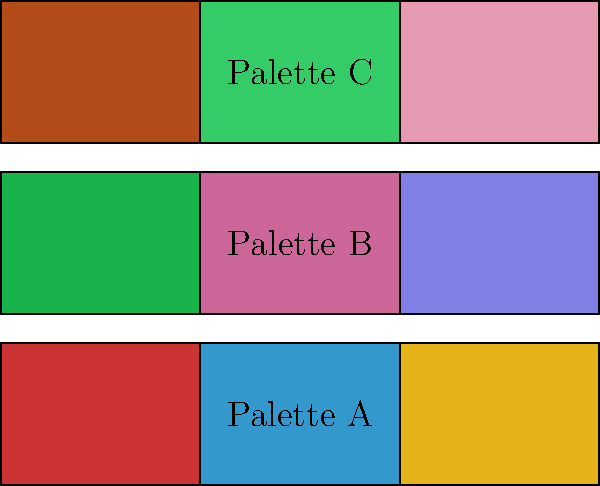Analyze the color palettes shown above, which are inspired by famous European street art murals. Which palette would be most effective for creating a mural that captures the vibrant energy of Barcelona's Las Ramblas district, and why? To answer this question, we need to consider the characteristics of Barcelona's Las Ramblas district and how each color palette might reflect its atmosphere:

1. Las Ramblas characteristics:
   - Vibrant and lively pedestrian street
   - Colorful flower stalls and street performers
   - Mediterranean influence with warm sunlight

2. Palette A analysis:
   - Contains warm red, cool blue, and bright yellow
   - High contrast and energy
   - Resembles the Spanish flag colors (red and yellow)

3. Palette B analysis:
   - Consists of cool green, warm pink, and muted blue
   - Softer contrast and more subdued energy
   - Lacks warm, vibrant tones associated with Mediterranean atmosphere

4. Palette C analysis:
   - Features warm terracotta, bright green, and soft pink
   - Balanced contrast with warm and cool tones
   - Evokes Mediterranean landscapes and architecture

5. Comparison and selection:
   - Palette A best captures the vibrant energy of Las Ramblas
   - The red and yellow reflect Spanish cultural colors
   - The bright blue adds contrast and represents the nearby sea
   - The high-energy combination aligns with the lively street atmosphere

Therefore, Palette A would be most effective for creating a mural that captures the vibrant energy of Barcelona's Las Ramblas district.
Answer: Palette A 